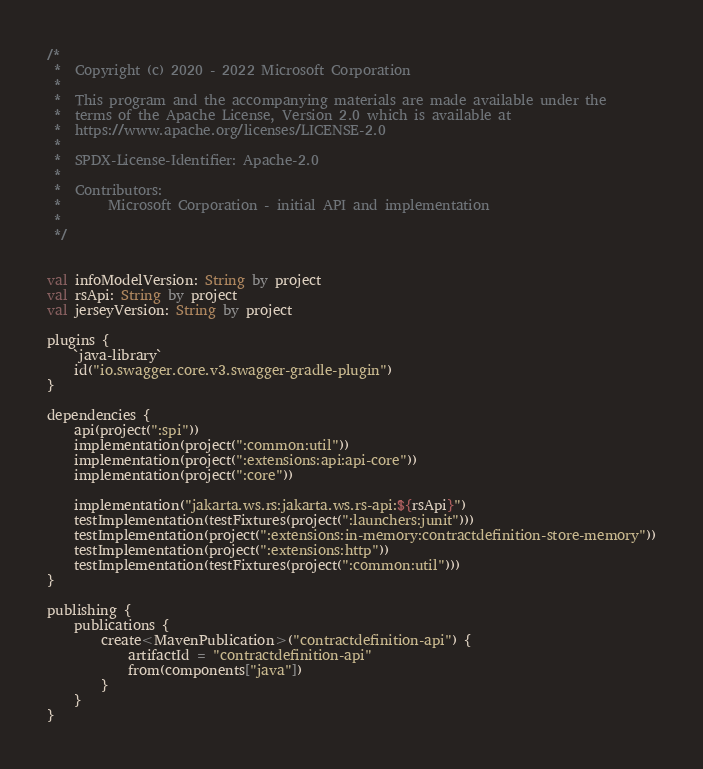Convert code to text. <code><loc_0><loc_0><loc_500><loc_500><_Kotlin_>/*
 *  Copyright (c) 2020 - 2022 Microsoft Corporation
 *
 *  This program and the accompanying materials are made available under the
 *  terms of the Apache License, Version 2.0 which is available at
 *  https://www.apache.org/licenses/LICENSE-2.0
 *
 *  SPDX-License-Identifier: Apache-2.0
 *
 *  Contributors:
 *       Microsoft Corporation - initial API and implementation
 *
 */


val infoModelVersion: String by project
val rsApi: String by project
val jerseyVersion: String by project

plugins {
    `java-library`
    id("io.swagger.core.v3.swagger-gradle-plugin")
}

dependencies {
    api(project(":spi"))
    implementation(project(":common:util"))
    implementation(project(":extensions:api:api-core"))
    implementation(project(":core"))

    implementation("jakarta.ws.rs:jakarta.ws.rs-api:${rsApi}")
    testImplementation(testFixtures(project(":launchers:junit")))
    testImplementation(project(":extensions:in-memory:contractdefinition-store-memory"))
    testImplementation(project(":extensions:http"))
    testImplementation(testFixtures(project(":common:util")))
}

publishing {
    publications {
        create<MavenPublication>("contractdefinition-api") {
            artifactId = "contractdefinition-api"
            from(components["java"])
        }
    }
}
</code> 